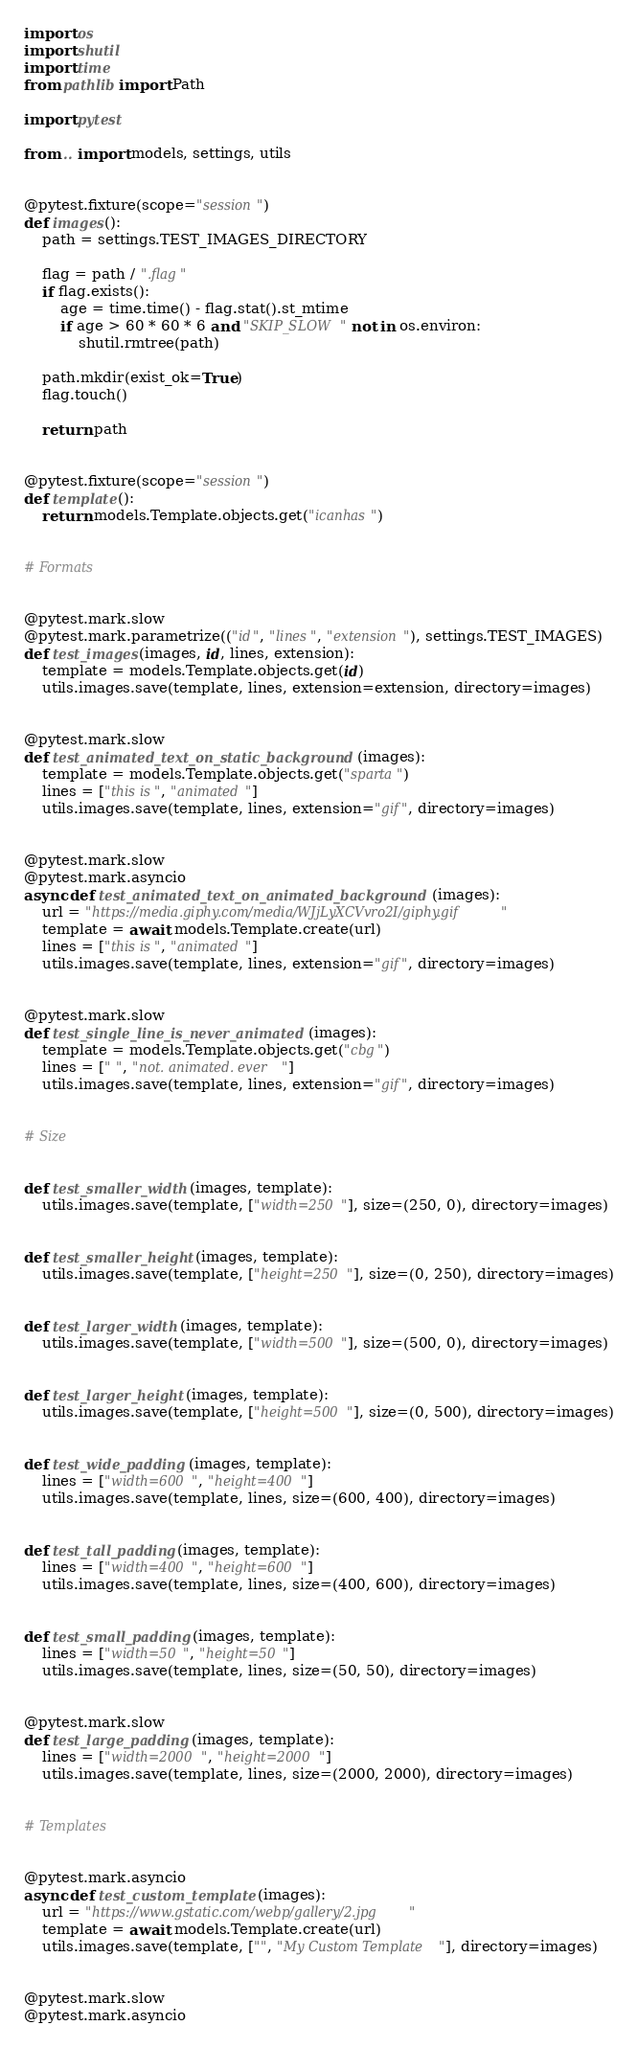<code> <loc_0><loc_0><loc_500><loc_500><_Python_>import os
import shutil
import time
from pathlib import Path

import pytest

from .. import models, settings, utils


@pytest.fixture(scope="session")
def images():
    path = settings.TEST_IMAGES_DIRECTORY

    flag = path / ".flag"
    if flag.exists():
        age = time.time() - flag.stat().st_mtime
        if age > 60 * 60 * 6 and "SKIP_SLOW" not in os.environ:
            shutil.rmtree(path)

    path.mkdir(exist_ok=True)
    flag.touch()

    return path


@pytest.fixture(scope="session")
def template():
    return models.Template.objects.get("icanhas")


# Formats


@pytest.mark.slow
@pytest.mark.parametrize(("id", "lines", "extension"), settings.TEST_IMAGES)
def test_images(images, id, lines, extension):
    template = models.Template.objects.get(id)
    utils.images.save(template, lines, extension=extension, directory=images)


@pytest.mark.slow
def test_animated_text_on_static_background(images):
    template = models.Template.objects.get("sparta")
    lines = ["this is", "animated"]
    utils.images.save(template, lines, extension="gif", directory=images)


@pytest.mark.slow
@pytest.mark.asyncio
async def test_animated_text_on_animated_background(images):
    url = "https://media.giphy.com/media/WJjLyXCVvro2I/giphy.gif"
    template = await models.Template.create(url)
    lines = ["this is", "animated"]
    utils.images.save(template, lines, extension="gif", directory=images)


@pytest.mark.slow
def test_single_line_is_never_animated(images):
    template = models.Template.objects.get("cbg")
    lines = [" ", "not. animated. ever"]
    utils.images.save(template, lines, extension="gif", directory=images)


# Size


def test_smaller_width(images, template):
    utils.images.save(template, ["width=250"], size=(250, 0), directory=images)


def test_smaller_height(images, template):
    utils.images.save(template, ["height=250"], size=(0, 250), directory=images)


def test_larger_width(images, template):
    utils.images.save(template, ["width=500"], size=(500, 0), directory=images)


def test_larger_height(images, template):
    utils.images.save(template, ["height=500"], size=(0, 500), directory=images)


def test_wide_padding(images, template):
    lines = ["width=600", "height=400"]
    utils.images.save(template, lines, size=(600, 400), directory=images)


def test_tall_padding(images, template):
    lines = ["width=400", "height=600"]
    utils.images.save(template, lines, size=(400, 600), directory=images)


def test_small_padding(images, template):
    lines = ["width=50", "height=50"]
    utils.images.save(template, lines, size=(50, 50), directory=images)


@pytest.mark.slow
def test_large_padding(images, template):
    lines = ["width=2000", "height=2000"]
    utils.images.save(template, lines, size=(2000, 2000), directory=images)


# Templates


@pytest.mark.asyncio
async def test_custom_template(images):
    url = "https://www.gstatic.com/webp/gallery/2.jpg"
    template = await models.Template.create(url)
    utils.images.save(template, ["", "My Custom Template"], directory=images)


@pytest.mark.slow
@pytest.mark.asyncio</code> 